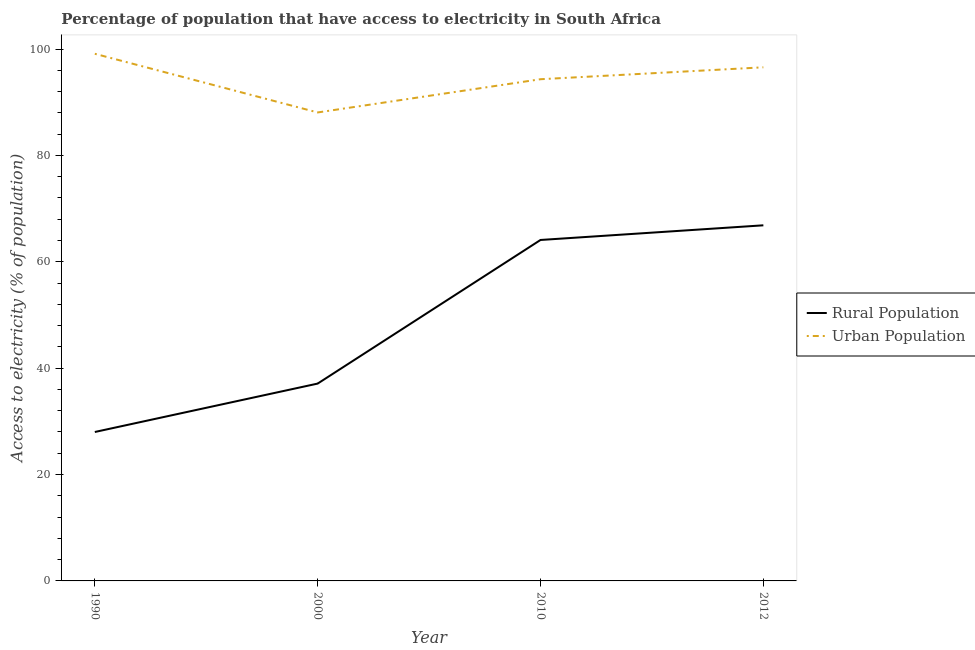How many different coloured lines are there?
Provide a succinct answer. 2. Does the line corresponding to percentage of urban population having access to electricity intersect with the line corresponding to percentage of rural population having access to electricity?
Make the answer very short. No. Is the number of lines equal to the number of legend labels?
Ensure brevity in your answer.  Yes. What is the percentage of urban population having access to electricity in 1990?
Provide a short and direct response. 99.1. Across all years, what is the maximum percentage of urban population having access to electricity?
Offer a very short reply. 99.1. Across all years, what is the minimum percentage of urban population having access to electricity?
Offer a very short reply. 88.07. In which year was the percentage of rural population having access to electricity minimum?
Your answer should be very brief. 1990. What is the total percentage of urban population having access to electricity in the graph?
Offer a terse response. 378.06. What is the difference between the percentage of rural population having access to electricity in 2010 and that in 2012?
Give a very brief answer. -2.75. What is the difference between the percentage of urban population having access to electricity in 1990 and the percentage of rural population having access to electricity in 2012?
Offer a terse response. 32.25. What is the average percentage of urban population having access to electricity per year?
Provide a short and direct response. 94.52. In the year 1990, what is the difference between the percentage of urban population having access to electricity and percentage of rural population having access to electricity?
Provide a short and direct response. 71.1. In how many years, is the percentage of rural population having access to electricity greater than 16 %?
Provide a succinct answer. 4. What is the ratio of the percentage of urban population having access to electricity in 2010 to that in 2012?
Provide a succinct answer. 0.98. Is the difference between the percentage of urban population having access to electricity in 2000 and 2012 greater than the difference between the percentage of rural population having access to electricity in 2000 and 2012?
Your response must be concise. Yes. What is the difference between the highest and the second highest percentage of urban population having access to electricity?
Ensure brevity in your answer.  2.54. What is the difference between the highest and the lowest percentage of rural population having access to electricity?
Give a very brief answer. 38.85. Is the sum of the percentage of rural population having access to electricity in 1990 and 2000 greater than the maximum percentage of urban population having access to electricity across all years?
Provide a short and direct response. No. Does the percentage of urban population having access to electricity monotonically increase over the years?
Make the answer very short. No. What is the difference between two consecutive major ticks on the Y-axis?
Provide a short and direct response. 20. Where does the legend appear in the graph?
Ensure brevity in your answer.  Center right. How are the legend labels stacked?
Make the answer very short. Vertical. What is the title of the graph?
Ensure brevity in your answer.  Percentage of population that have access to electricity in South Africa. Does "Goods" appear as one of the legend labels in the graph?
Provide a succinct answer. No. What is the label or title of the Y-axis?
Provide a short and direct response. Access to electricity (% of population). What is the Access to electricity (% of population) of Urban Population in 1990?
Offer a terse response. 99.1. What is the Access to electricity (% of population) in Rural Population in 2000?
Offer a very short reply. 37.1. What is the Access to electricity (% of population) of Urban Population in 2000?
Your answer should be very brief. 88.07. What is the Access to electricity (% of population) of Rural Population in 2010?
Your answer should be compact. 64.1. What is the Access to electricity (% of population) of Urban Population in 2010?
Give a very brief answer. 94.32. What is the Access to electricity (% of population) of Rural Population in 2012?
Offer a very short reply. 66.85. What is the Access to electricity (% of population) of Urban Population in 2012?
Your response must be concise. 96.56. Across all years, what is the maximum Access to electricity (% of population) of Rural Population?
Ensure brevity in your answer.  66.85. Across all years, what is the maximum Access to electricity (% of population) in Urban Population?
Your answer should be compact. 99.1. Across all years, what is the minimum Access to electricity (% of population) of Urban Population?
Offer a terse response. 88.07. What is the total Access to electricity (% of population) in Rural Population in the graph?
Ensure brevity in your answer.  196.05. What is the total Access to electricity (% of population) in Urban Population in the graph?
Provide a short and direct response. 378.06. What is the difference between the Access to electricity (% of population) in Urban Population in 1990 and that in 2000?
Give a very brief answer. 11.03. What is the difference between the Access to electricity (% of population) in Rural Population in 1990 and that in 2010?
Ensure brevity in your answer.  -36.1. What is the difference between the Access to electricity (% of population) in Urban Population in 1990 and that in 2010?
Ensure brevity in your answer.  4.78. What is the difference between the Access to electricity (% of population) in Rural Population in 1990 and that in 2012?
Your answer should be compact. -38.85. What is the difference between the Access to electricity (% of population) of Urban Population in 1990 and that in 2012?
Your answer should be compact. 2.54. What is the difference between the Access to electricity (% of population) of Urban Population in 2000 and that in 2010?
Give a very brief answer. -6.25. What is the difference between the Access to electricity (% of population) of Rural Population in 2000 and that in 2012?
Keep it short and to the point. -29.75. What is the difference between the Access to electricity (% of population) of Urban Population in 2000 and that in 2012?
Your response must be concise. -8.49. What is the difference between the Access to electricity (% of population) of Rural Population in 2010 and that in 2012?
Provide a short and direct response. -2.75. What is the difference between the Access to electricity (% of population) of Urban Population in 2010 and that in 2012?
Provide a succinct answer. -2.24. What is the difference between the Access to electricity (% of population) of Rural Population in 1990 and the Access to electricity (% of population) of Urban Population in 2000?
Ensure brevity in your answer.  -60.07. What is the difference between the Access to electricity (% of population) in Rural Population in 1990 and the Access to electricity (% of population) in Urban Population in 2010?
Offer a very short reply. -66.32. What is the difference between the Access to electricity (% of population) of Rural Population in 1990 and the Access to electricity (% of population) of Urban Population in 2012?
Provide a succinct answer. -68.56. What is the difference between the Access to electricity (% of population) of Rural Population in 2000 and the Access to electricity (% of population) of Urban Population in 2010?
Provide a succinct answer. -57.22. What is the difference between the Access to electricity (% of population) in Rural Population in 2000 and the Access to electricity (% of population) in Urban Population in 2012?
Give a very brief answer. -59.46. What is the difference between the Access to electricity (% of population) of Rural Population in 2010 and the Access to electricity (% of population) of Urban Population in 2012?
Keep it short and to the point. -32.46. What is the average Access to electricity (% of population) in Rural Population per year?
Your answer should be compact. 49.01. What is the average Access to electricity (% of population) of Urban Population per year?
Provide a succinct answer. 94.52. In the year 1990, what is the difference between the Access to electricity (% of population) in Rural Population and Access to electricity (% of population) in Urban Population?
Offer a terse response. -71.1. In the year 2000, what is the difference between the Access to electricity (% of population) of Rural Population and Access to electricity (% of population) of Urban Population?
Offer a terse response. -50.97. In the year 2010, what is the difference between the Access to electricity (% of population) in Rural Population and Access to electricity (% of population) in Urban Population?
Provide a short and direct response. -30.22. In the year 2012, what is the difference between the Access to electricity (% of population) of Rural Population and Access to electricity (% of population) of Urban Population?
Offer a very short reply. -29.71. What is the ratio of the Access to electricity (% of population) of Rural Population in 1990 to that in 2000?
Provide a succinct answer. 0.75. What is the ratio of the Access to electricity (% of population) in Urban Population in 1990 to that in 2000?
Your answer should be compact. 1.13. What is the ratio of the Access to electricity (% of population) in Rural Population in 1990 to that in 2010?
Provide a succinct answer. 0.44. What is the ratio of the Access to electricity (% of population) of Urban Population in 1990 to that in 2010?
Your response must be concise. 1.05. What is the ratio of the Access to electricity (% of population) of Rural Population in 1990 to that in 2012?
Make the answer very short. 0.42. What is the ratio of the Access to electricity (% of population) of Urban Population in 1990 to that in 2012?
Your answer should be compact. 1.03. What is the ratio of the Access to electricity (% of population) in Rural Population in 2000 to that in 2010?
Your answer should be compact. 0.58. What is the ratio of the Access to electricity (% of population) of Urban Population in 2000 to that in 2010?
Make the answer very short. 0.93. What is the ratio of the Access to electricity (% of population) of Rural Population in 2000 to that in 2012?
Give a very brief answer. 0.55. What is the ratio of the Access to electricity (% of population) of Urban Population in 2000 to that in 2012?
Ensure brevity in your answer.  0.91. What is the ratio of the Access to electricity (% of population) of Rural Population in 2010 to that in 2012?
Ensure brevity in your answer.  0.96. What is the ratio of the Access to electricity (% of population) in Urban Population in 2010 to that in 2012?
Give a very brief answer. 0.98. What is the difference between the highest and the second highest Access to electricity (% of population) in Rural Population?
Your response must be concise. 2.75. What is the difference between the highest and the second highest Access to electricity (% of population) of Urban Population?
Provide a succinct answer. 2.54. What is the difference between the highest and the lowest Access to electricity (% of population) in Rural Population?
Your answer should be compact. 38.85. What is the difference between the highest and the lowest Access to electricity (% of population) in Urban Population?
Ensure brevity in your answer.  11.03. 